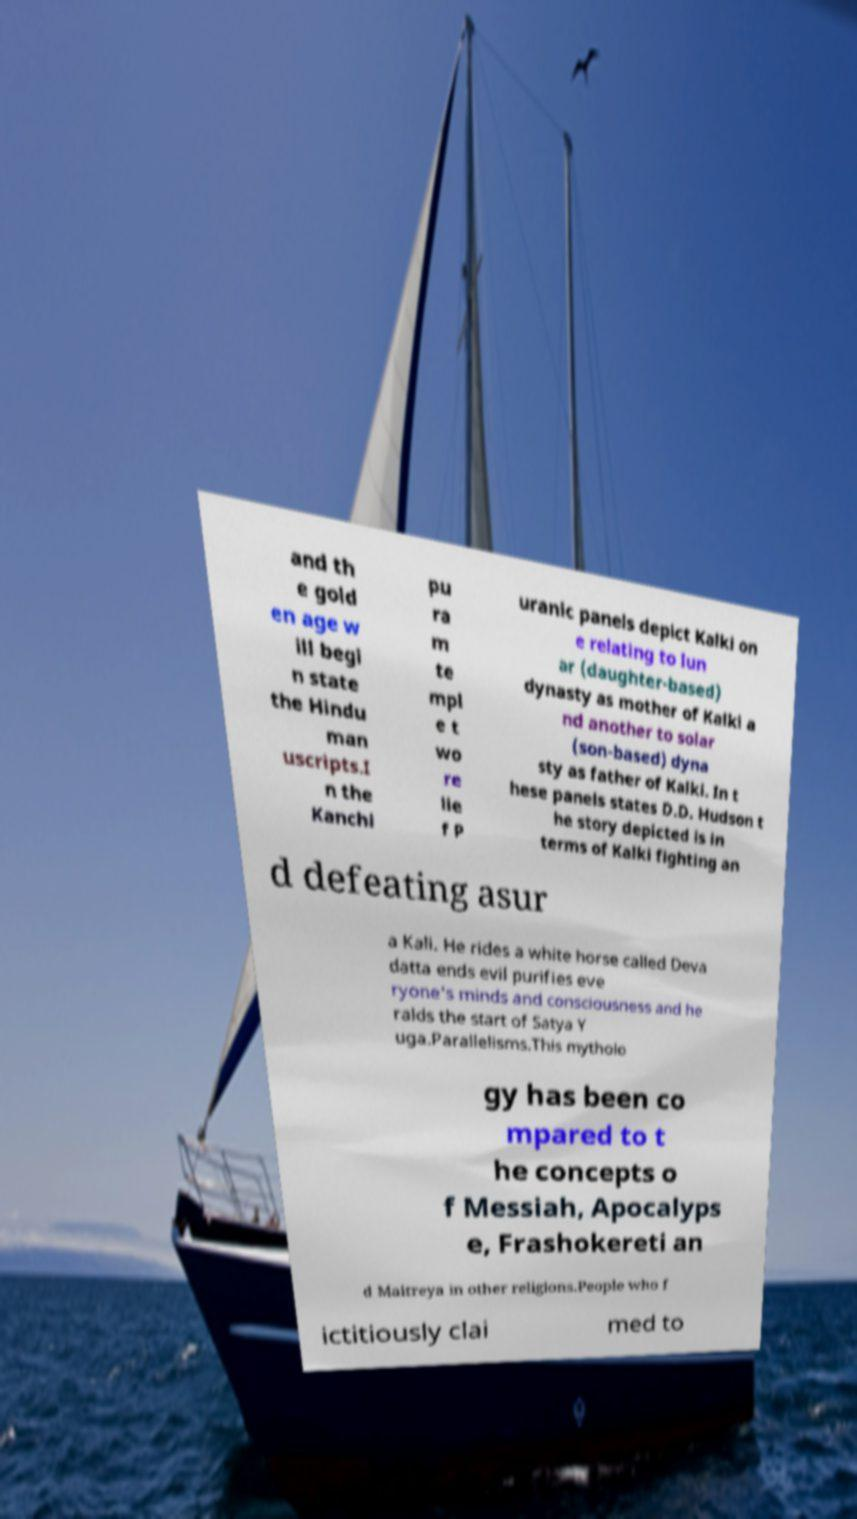I need the written content from this picture converted into text. Can you do that? and th e gold en age w ill begi n state the Hindu man uscripts.I n the Kanchi pu ra m te mpl e t wo re lie f P uranic panels depict Kalki on e relating to lun ar (daughter-based) dynasty as mother of Kalki a nd another to solar (son-based) dyna sty as father of Kalki. In t hese panels states D.D. Hudson t he story depicted is in terms of Kalki fighting an d defeating asur a Kali. He rides a white horse called Deva datta ends evil purifies eve ryone's minds and consciousness and he ralds the start of Satya Y uga.Parallelisms.This mytholo gy has been co mpared to t he concepts o f Messiah, Apocalyps e, Frashokereti an d Maitreya in other religions.People who f ictitiously clai med to 